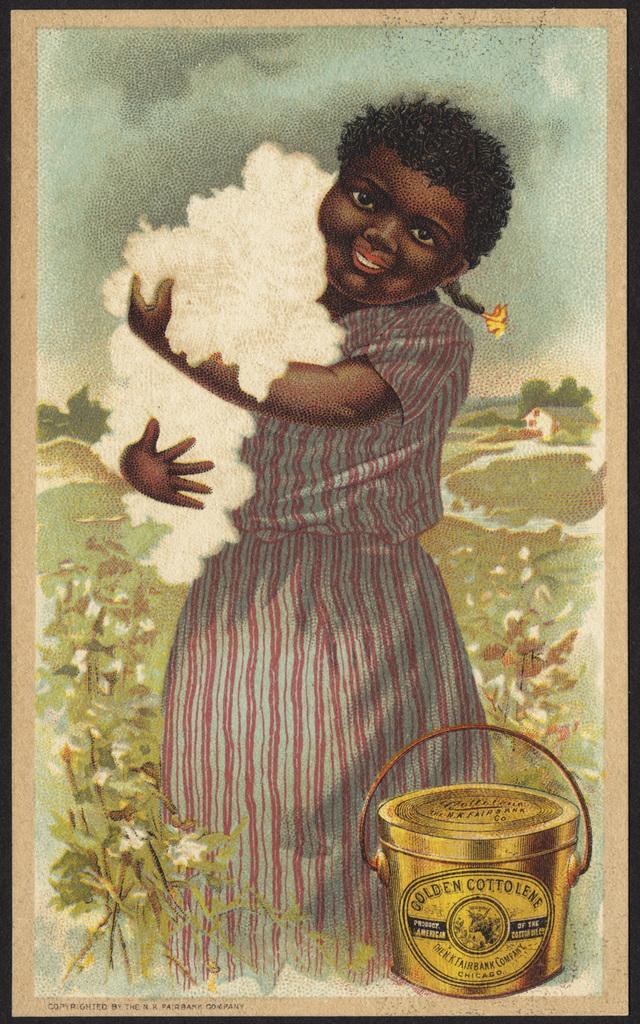What is the brand listed on the bucket?
Offer a terse response. Golden cottolene. What color is described on the bucket?
Offer a very short reply. Golden. 